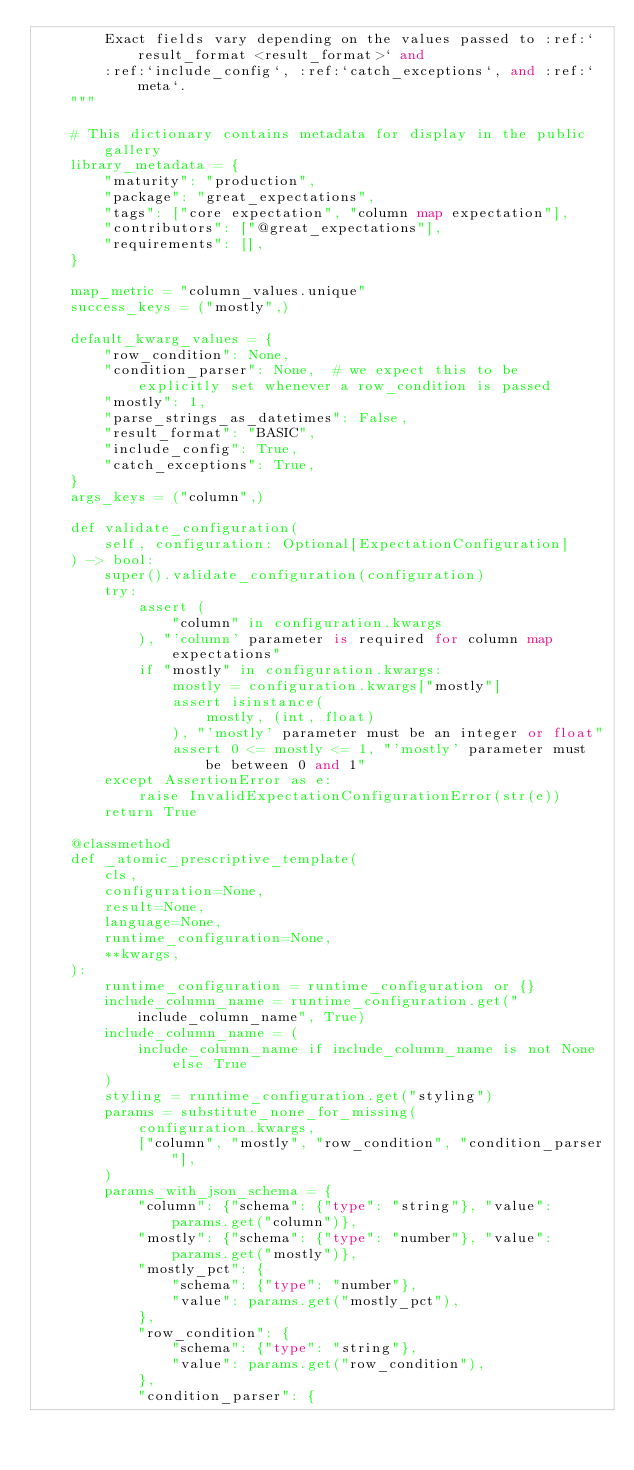Convert code to text. <code><loc_0><loc_0><loc_500><loc_500><_Python_>        Exact fields vary depending on the values passed to :ref:`result_format <result_format>` and
        :ref:`include_config`, :ref:`catch_exceptions`, and :ref:`meta`.
    """

    # This dictionary contains metadata for display in the public gallery
    library_metadata = {
        "maturity": "production",
        "package": "great_expectations",
        "tags": ["core expectation", "column map expectation"],
        "contributors": ["@great_expectations"],
        "requirements": [],
    }

    map_metric = "column_values.unique"
    success_keys = ("mostly",)

    default_kwarg_values = {
        "row_condition": None,
        "condition_parser": None,  # we expect this to be explicitly set whenever a row_condition is passed
        "mostly": 1,
        "parse_strings_as_datetimes": False,
        "result_format": "BASIC",
        "include_config": True,
        "catch_exceptions": True,
    }
    args_keys = ("column",)

    def validate_configuration(
        self, configuration: Optional[ExpectationConfiguration]
    ) -> bool:
        super().validate_configuration(configuration)
        try:
            assert (
                "column" in configuration.kwargs
            ), "'column' parameter is required for column map expectations"
            if "mostly" in configuration.kwargs:
                mostly = configuration.kwargs["mostly"]
                assert isinstance(
                    mostly, (int, float)
                ), "'mostly' parameter must be an integer or float"
                assert 0 <= mostly <= 1, "'mostly' parameter must be between 0 and 1"
        except AssertionError as e:
            raise InvalidExpectationConfigurationError(str(e))
        return True

    @classmethod
    def _atomic_prescriptive_template(
        cls,
        configuration=None,
        result=None,
        language=None,
        runtime_configuration=None,
        **kwargs,
    ):
        runtime_configuration = runtime_configuration or {}
        include_column_name = runtime_configuration.get("include_column_name", True)
        include_column_name = (
            include_column_name if include_column_name is not None else True
        )
        styling = runtime_configuration.get("styling")
        params = substitute_none_for_missing(
            configuration.kwargs,
            ["column", "mostly", "row_condition", "condition_parser"],
        )
        params_with_json_schema = {
            "column": {"schema": {"type": "string"}, "value": params.get("column")},
            "mostly": {"schema": {"type": "number"}, "value": params.get("mostly")},
            "mostly_pct": {
                "schema": {"type": "number"},
                "value": params.get("mostly_pct"),
            },
            "row_condition": {
                "schema": {"type": "string"},
                "value": params.get("row_condition"),
            },
            "condition_parser": {</code> 